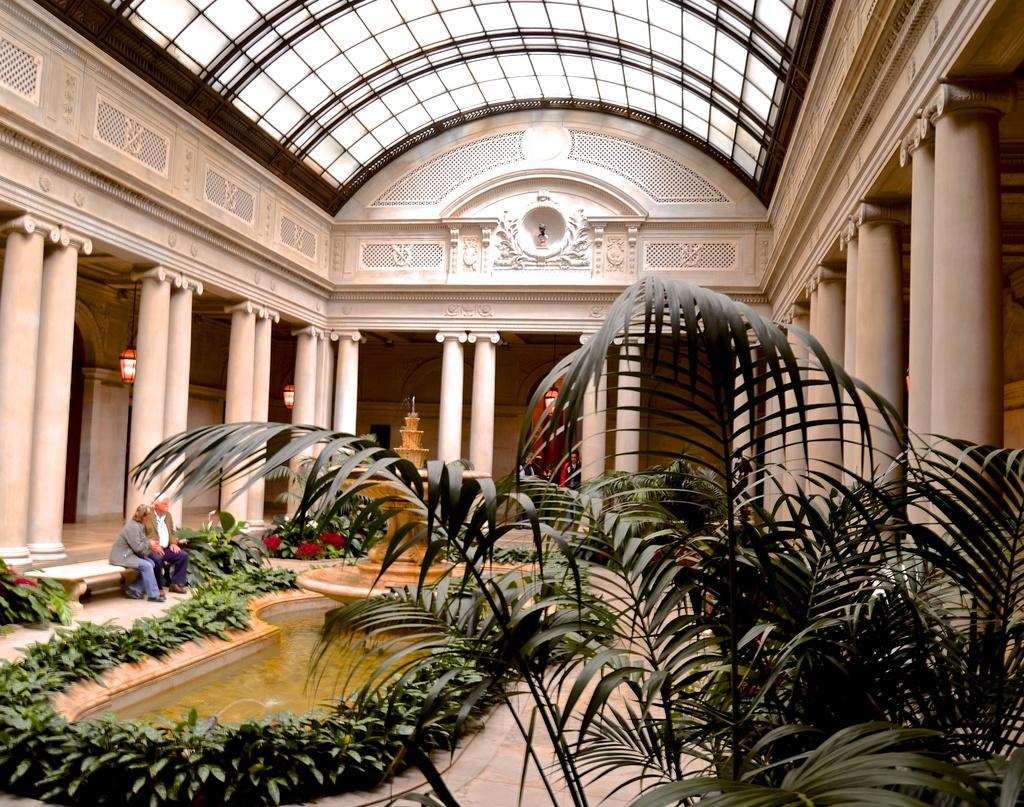How would you summarize this image in a sentence or two? In the foreground, I can see houseplants, water, fountain, two persons are sitting on a bench. In the background, I can see pillars, lamps and a rooftop. This image is taken, maybe during a day. 